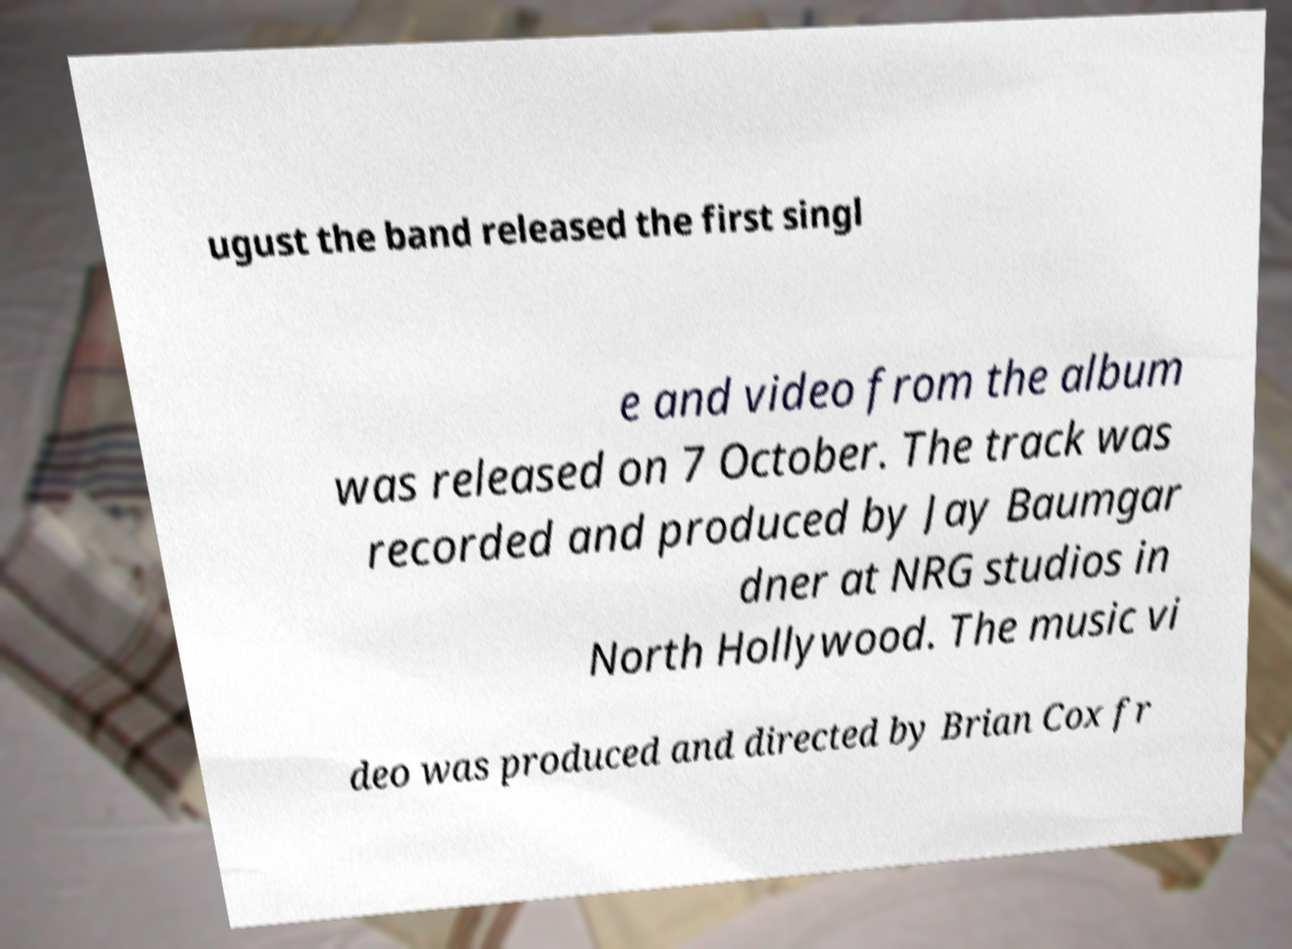Can you accurately transcribe the text from the provided image for me? ugust the band released the first singl e and video from the album was released on 7 October. The track was recorded and produced by Jay Baumgar dner at NRG studios in North Hollywood. The music vi deo was produced and directed by Brian Cox fr 